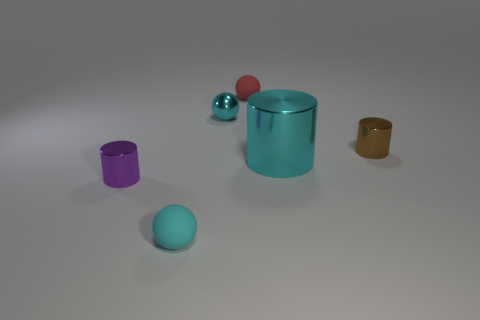Subtract all cyan rubber spheres. How many spheres are left? 2 Add 3 tiny metal objects. How many tiny metal objects are left? 6 Add 2 big red matte cylinders. How many big red matte cylinders exist? 2 Add 3 brown matte blocks. How many objects exist? 9 Subtract all cyan cylinders. How many cylinders are left? 2 Subtract 0 red cylinders. How many objects are left? 6 Subtract 2 cylinders. How many cylinders are left? 1 Subtract all brown spheres. Subtract all blue blocks. How many spheres are left? 3 Subtract all purple cubes. How many cyan balls are left? 2 Subtract all red things. Subtract all small brown shiny objects. How many objects are left? 4 